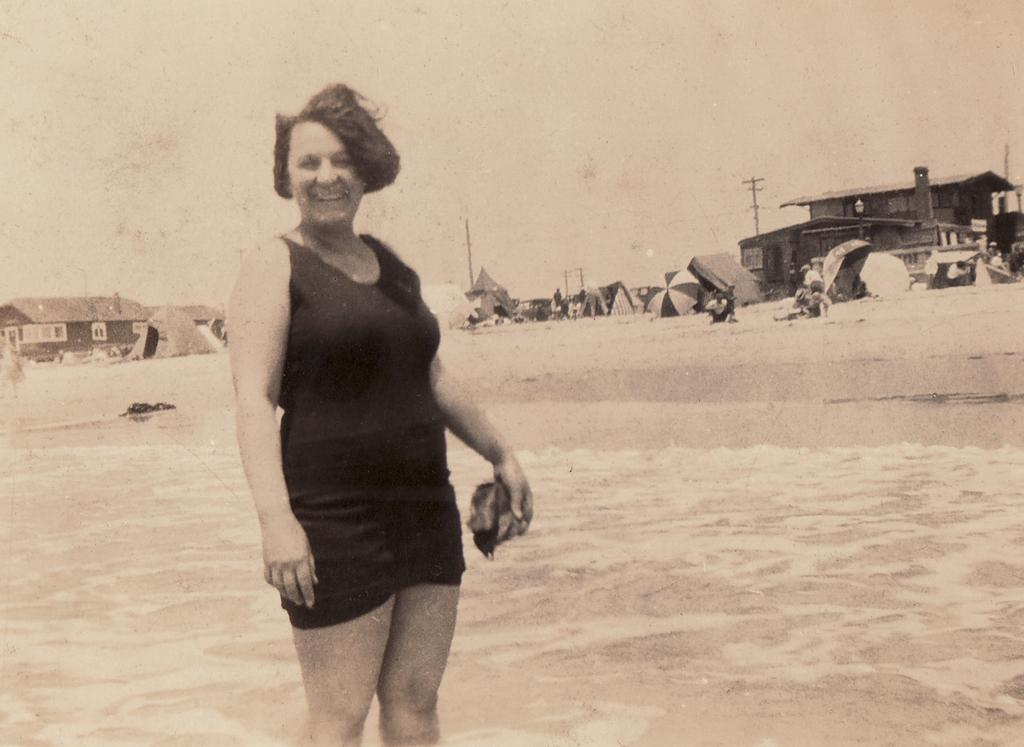What is the main subject in the foreground of the picture? There is a woman in the foreground of the picture. What is the woman wearing? The woman is in a black dress. What is the woman's location in the image? The woman is in the water. What can be seen in the background of the image? There are tents, umbrellas, poles, houses, and the sky visible in the background of the image. How many books can be seen in the woman's hands in the image? There are no books visible in the image; the woman is in the water and not holding any books. 